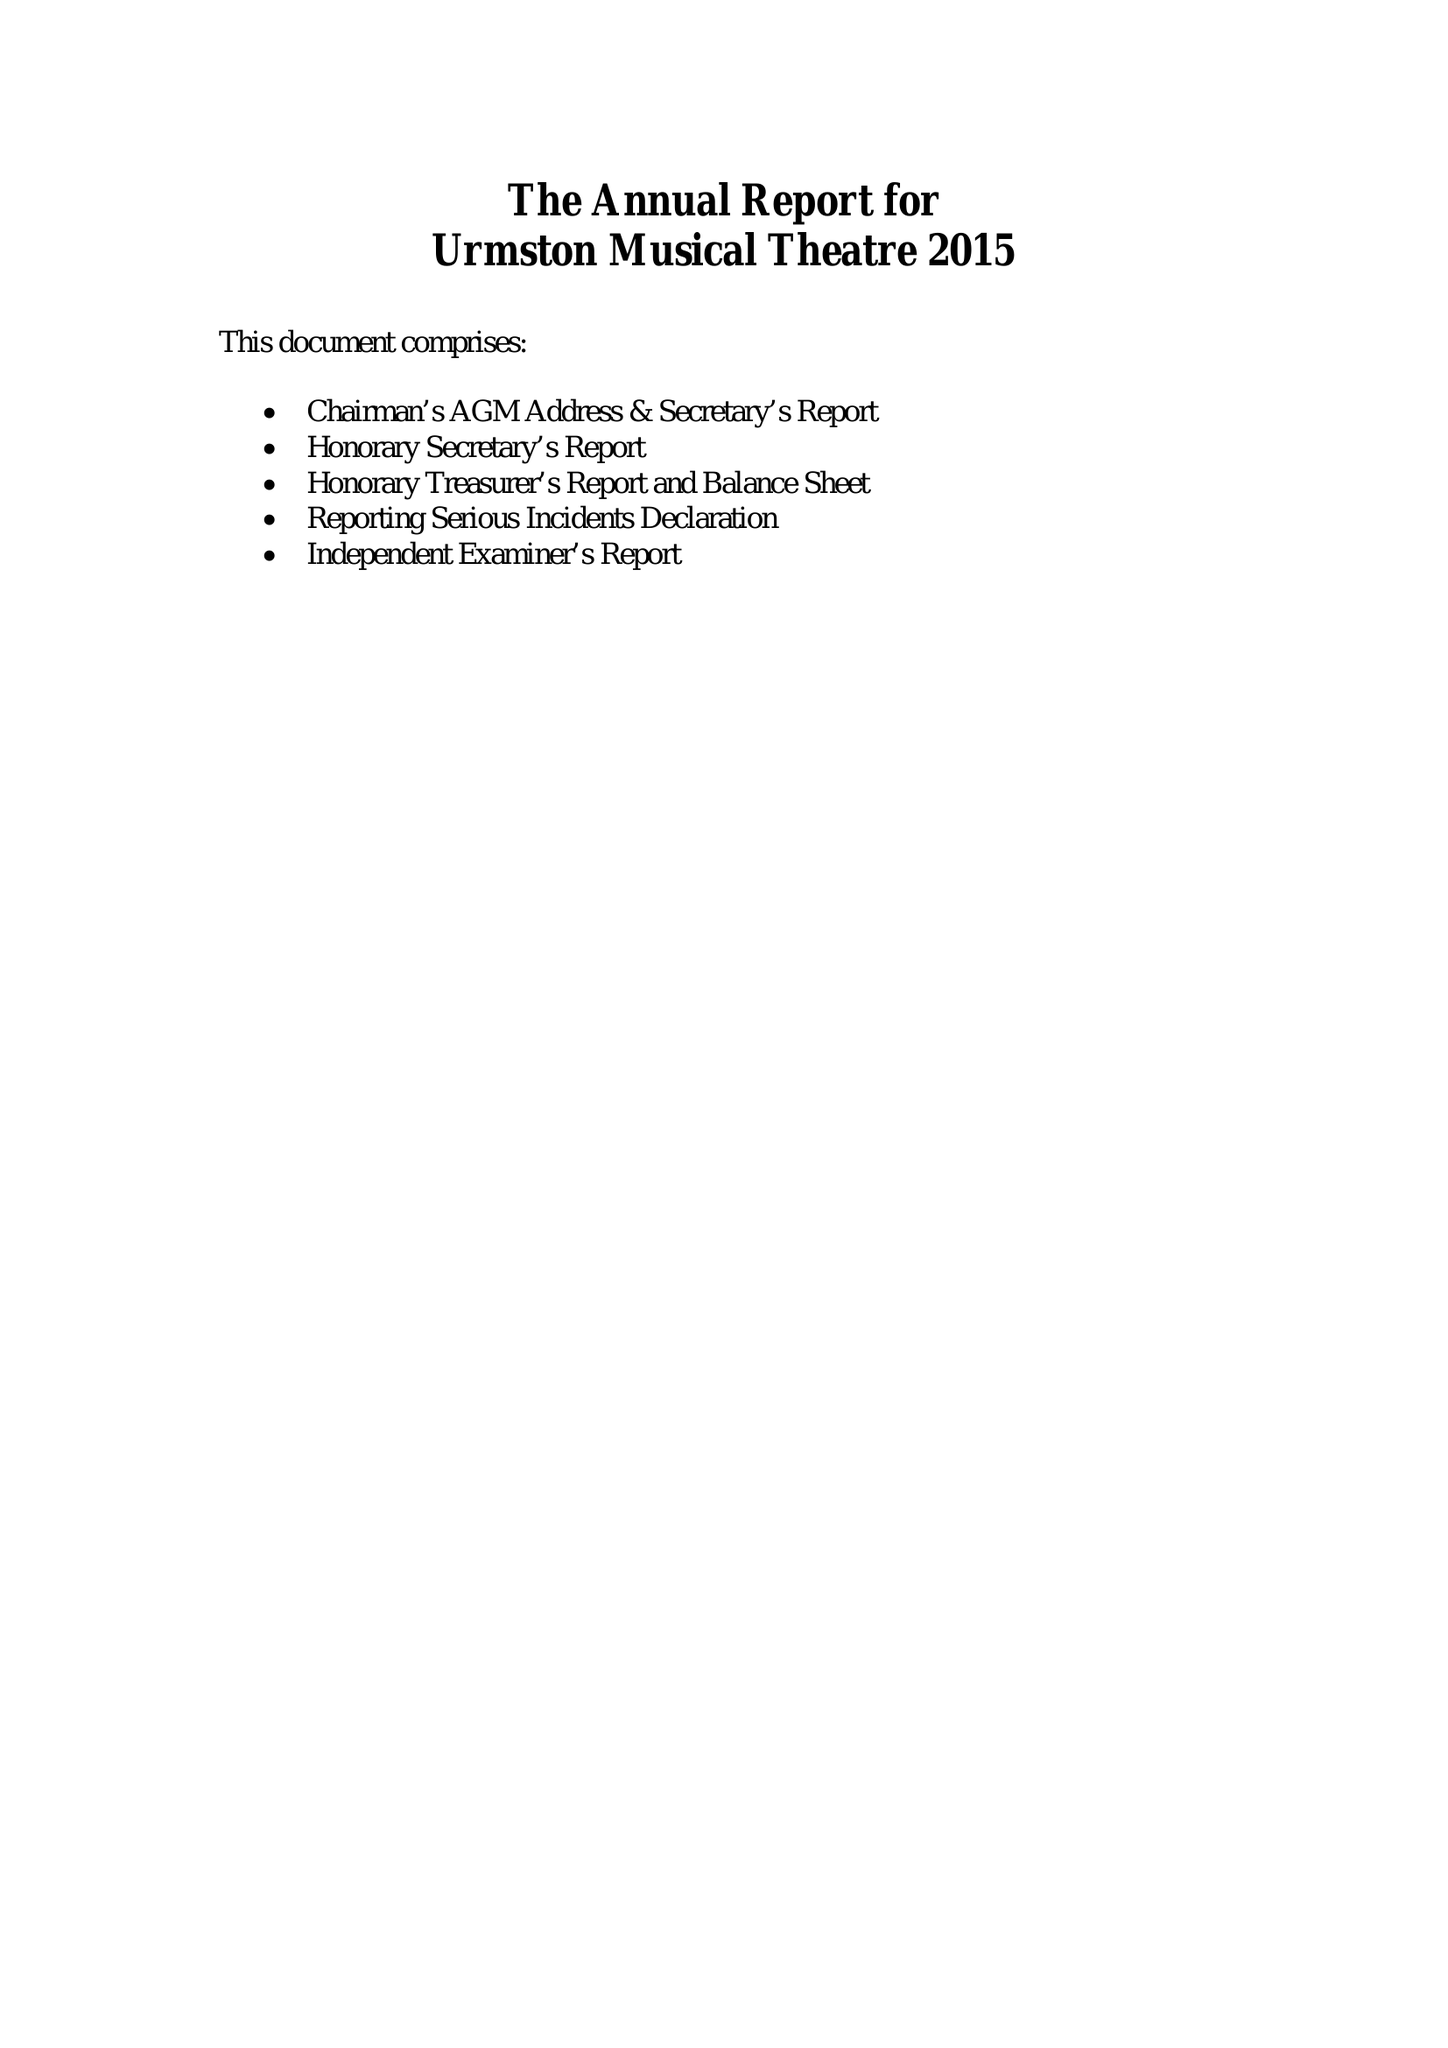What is the value for the address__post_town?
Answer the question using a single word or phrase. MANCHESTER 